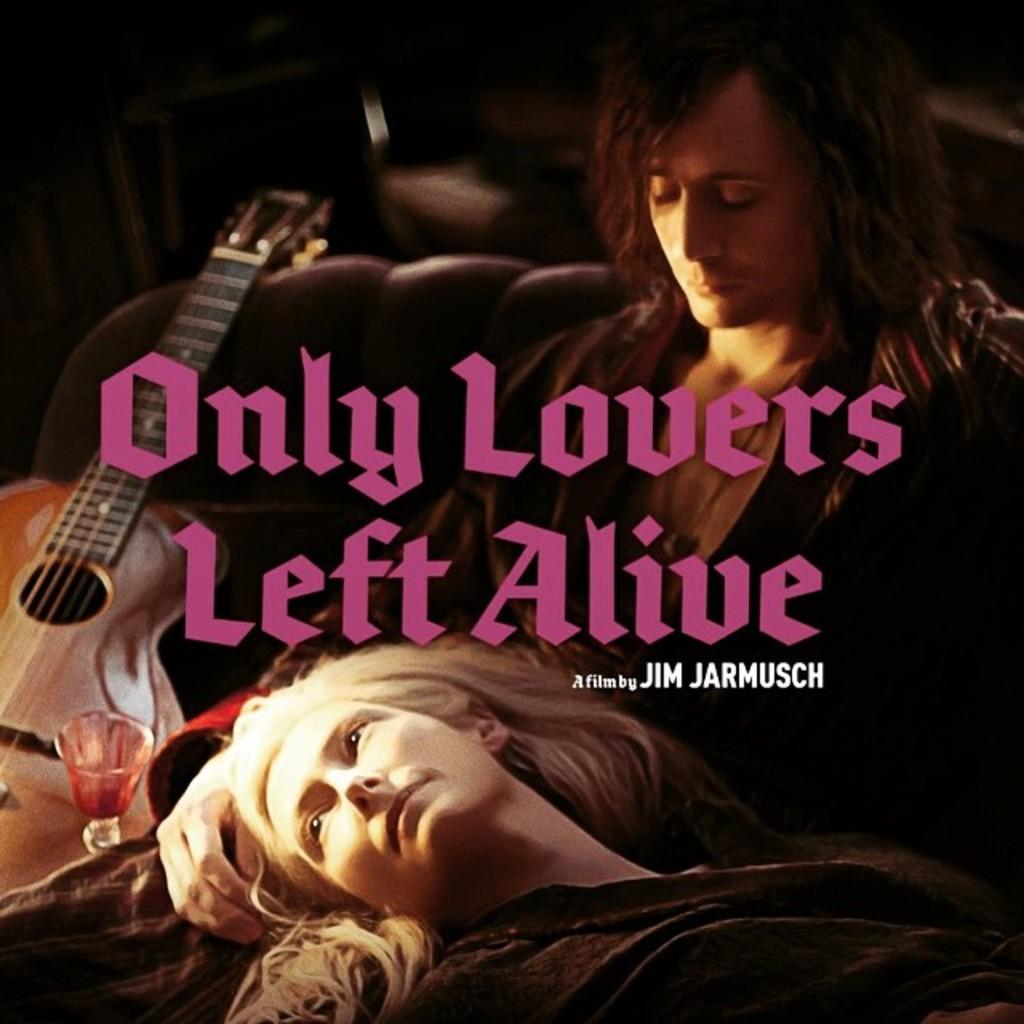How many people are sitting on the sofa in the image? There are two people sitting on the sofa in the image. What object can be seen in the image that is typically used for drinking? There is a glass in the image. What musical instrument is present in the image? There is a guitar in the image. What type of bridge can be seen connecting the two people on the sofa in the image? There is no bridge present in the image; it features two people sitting on a sofa with a guitar and a glass. 